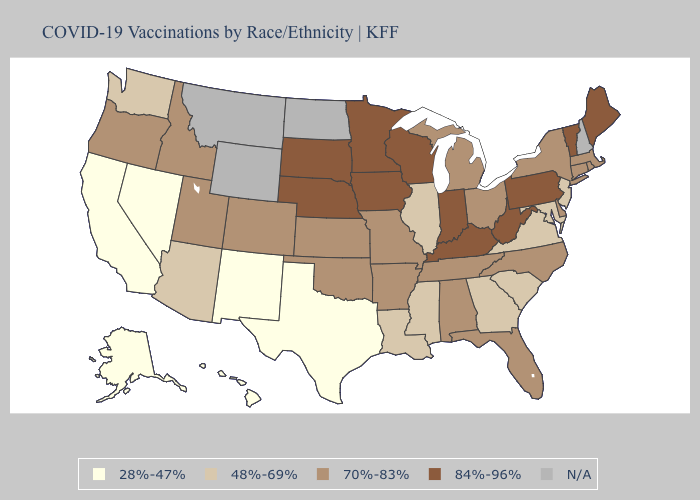Which states hav the highest value in the Northeast?
Short answer required. Maine, Pennsylvania, Vermont. What is the value of Louisiana?
Answer briefly. 48%-69%. Among the states that border Illinois , which have the lowest value?
Give a very brief answer. Missouri. What is the lowest value in the USA?
Keep it brief. 28%-47%. What is the value of Minnesota?
Be succinct. 84%-96%. Name the states that have a value in the range 48%-69%?
Answer briefly. Arizona, Georgia, Illinois, Louisiana, Maryland, Mississippi, New Jersey, South Carolina, Virginia, Washington. Name the states that have a value in the range 28%-47%?
Short answer required. Alaska, California, Hawaii, Nevada, New Mexico, Texas. Name the states that have a value in the range 70%-83%?
Quick response, please. Alabama, Arkansas, Colorado, Connecticut, Delaware, Florida, Idaho, Kansas, Massachusetts, Michigan, Missouri, New York, North Carolina, Ohio, Oklahoma, Oregon, Rhode Island, Tennessee, Utah. Name the states that have a value in the range N/A?
Keep it brief. Montana, New Hampshire, North Dakota, Wyoming. Name the states that have a value in the range 84%-96%?
Quick response, please. Indiana, Iowa, Kentucky, Maine, Minnesota, Nebraska, Pennsylvania, South Dakota, Vermont, West Virginia, Wisconsin. Name the states that have a value in the range 48%-69%?
Keep it brief. Arizona, Georgia, Illinois, Louisiana, Maryland, Mississippi, New Jersey, South Carolina, Virginia, Washington. Does Kansas have the highest value in the MidWest?
Short answer required. No. Does Texas have the lowest value in the USA?
Keep it brief. Yes. 